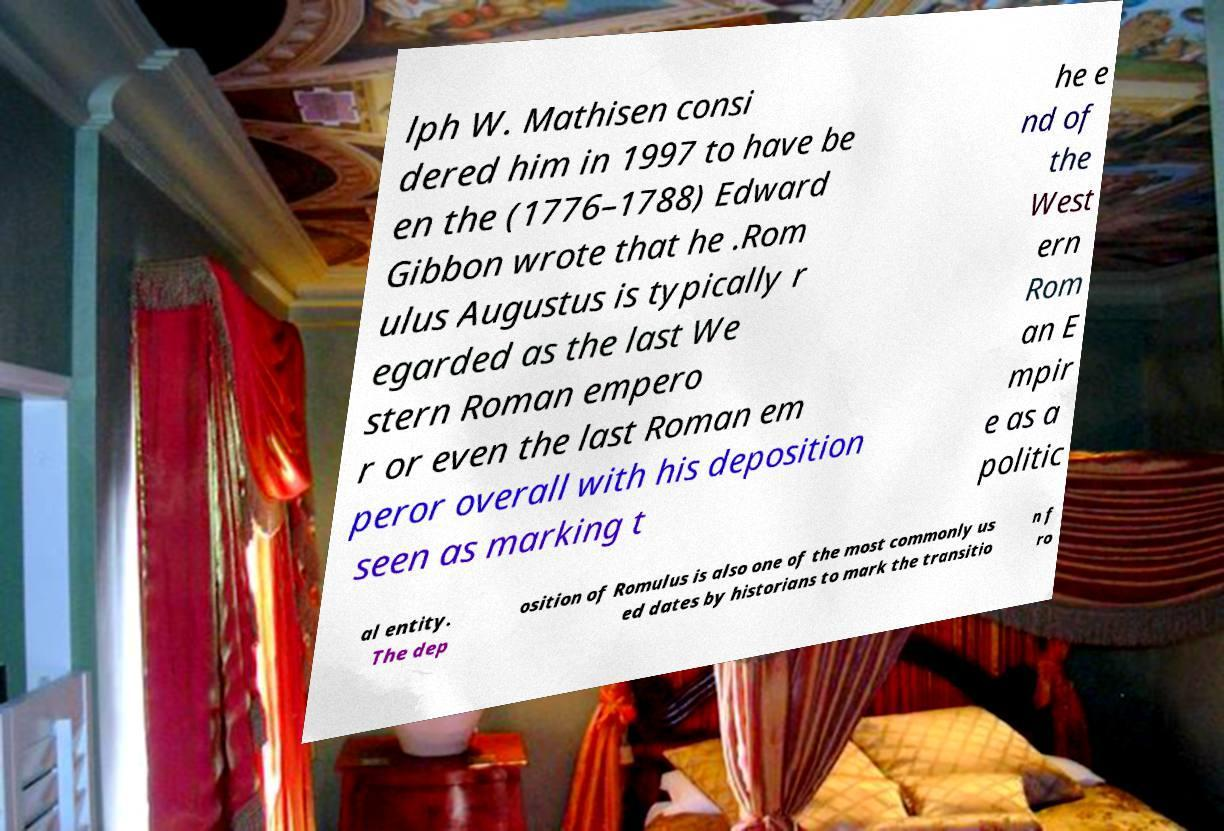Can you read and provide the text displayed in the image?This photo seems to have some interesting text. Can you extract and type it out for me? lph W. Mathisen consi dered him in 1997 to have be en the (1776–1788) Edward Gibbon wrote that he .Rom ulus Augustus is typically r egarded as the last We stern Roman empero r or even the last Roman em peror overall with his deposition seen as marking t he e nd of the West ern Rom an E mpir e as a politic al entity. The dep osition of Romulus is also one of the most commonly us ed dates by historians to mark the transitio n f ro 